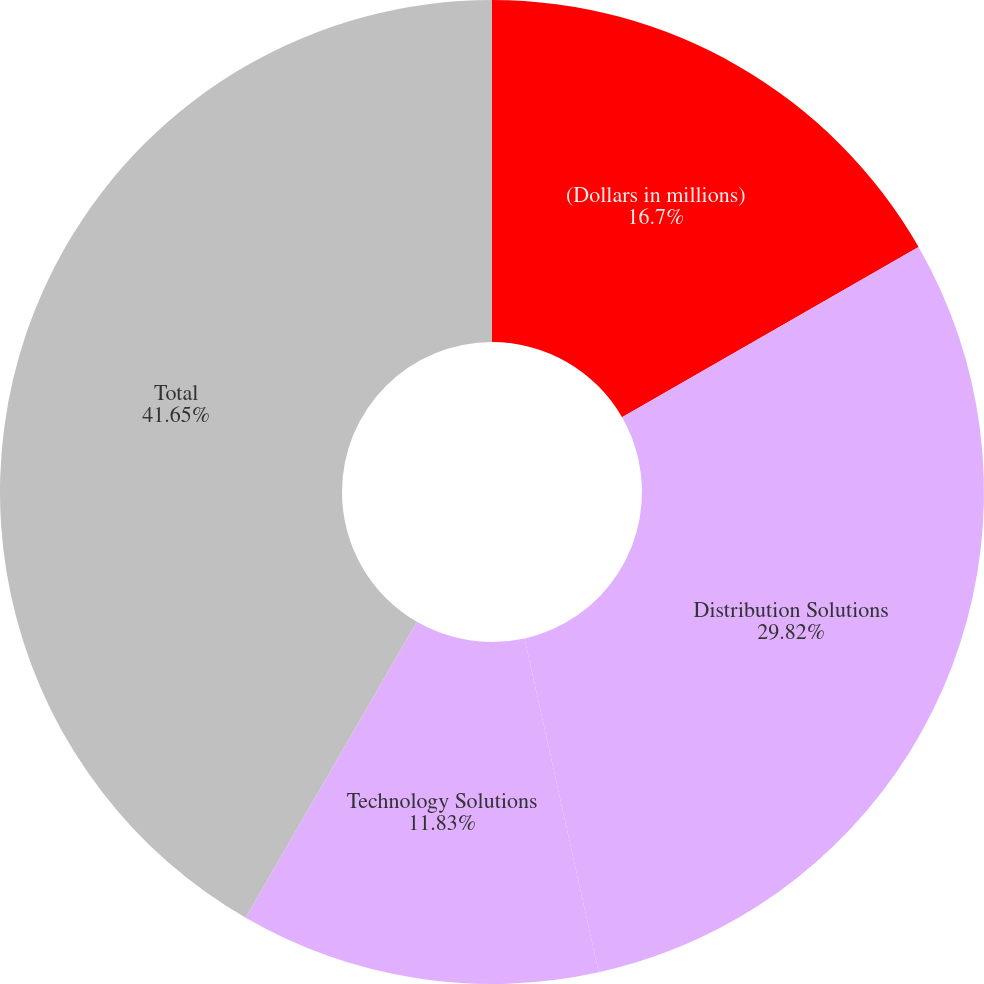<chart> <loc_0><loc_0><loc_500><loc_500><pie_chart><fcel>(Dollars in millions)<fcel>Distribution Solutions<fcel>Technology Solutions<fcel>Total<nl><fcel>16.7%<fcel>29.82%<fcel>11.83%<fcel>41.65%<nl></chart> 